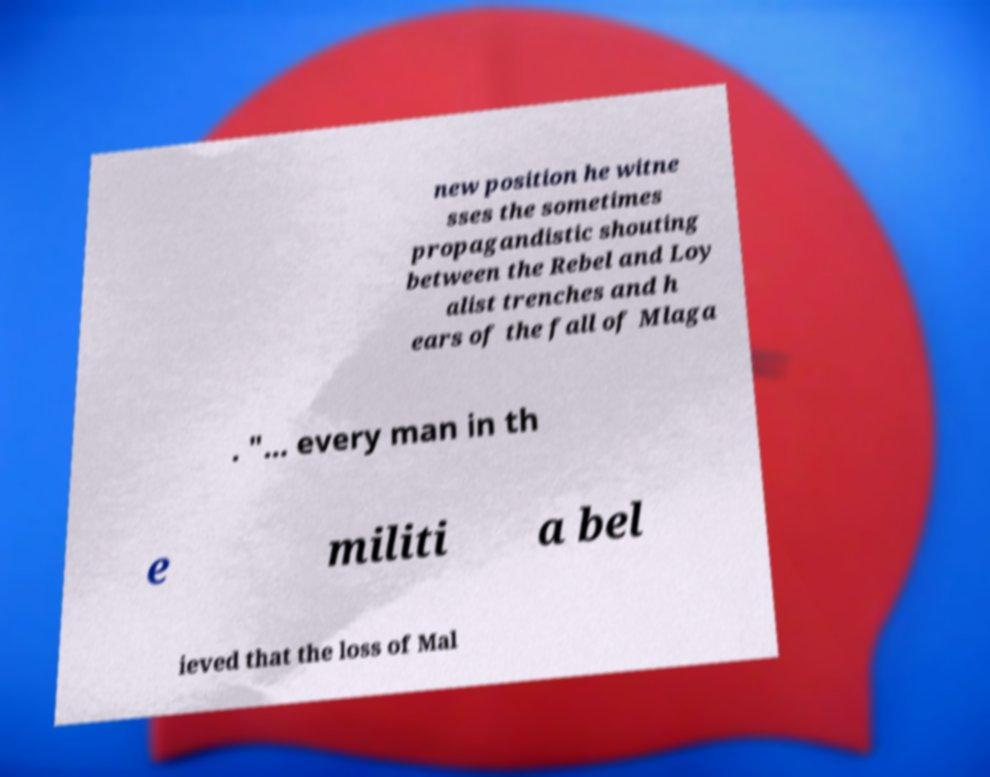I need the written content from this picture converted into text. Can you do that? new position he witne sses the sometimes propagandistic shouting between the Rebel and Loy alist trenches and h ears of the fall of Mlaga . "... every man in th e militi a bel ieved that the loss of Mal 